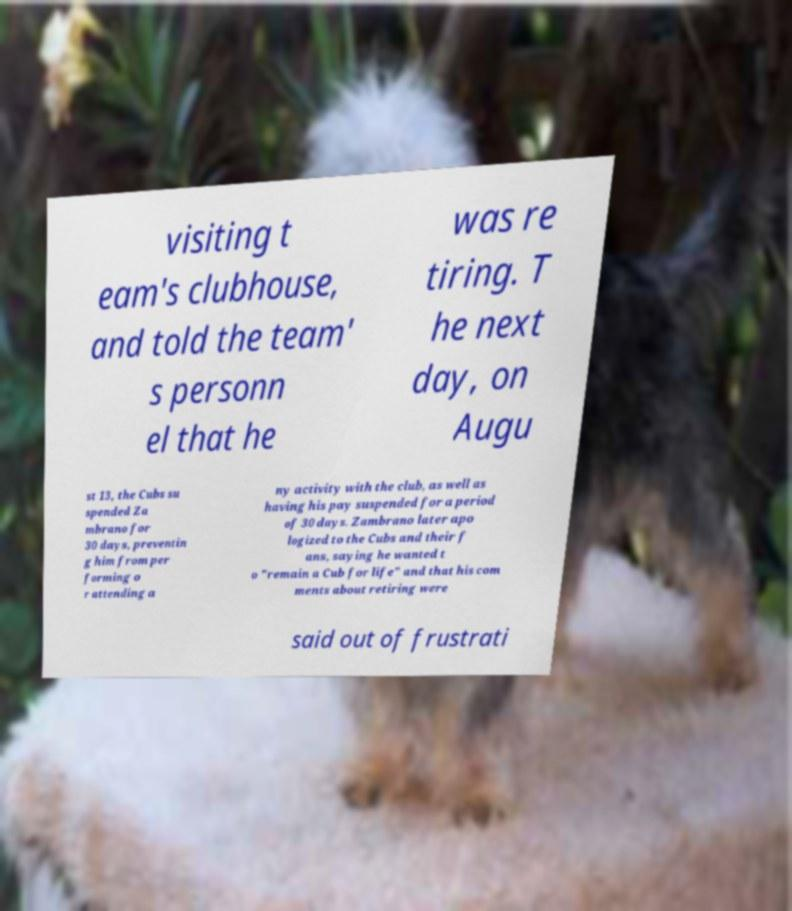I need the written content from this picture converted into text. Can you do that? visiting t eam's clubhouse, and told the team' s personn el that he was re tiring. T he next day, on Augu st 13, the Cubs su spended Za mbrano for 30 days, preventin g him from per forming o r attending a ny activity with the club, as well as having his pay suspended for a period of 30 days. Zambrano later apo logized to the Cubs and their f ans, saying he wanted t o "remain a Cub for life" and that his com ments about retiring were said out of frustrati 